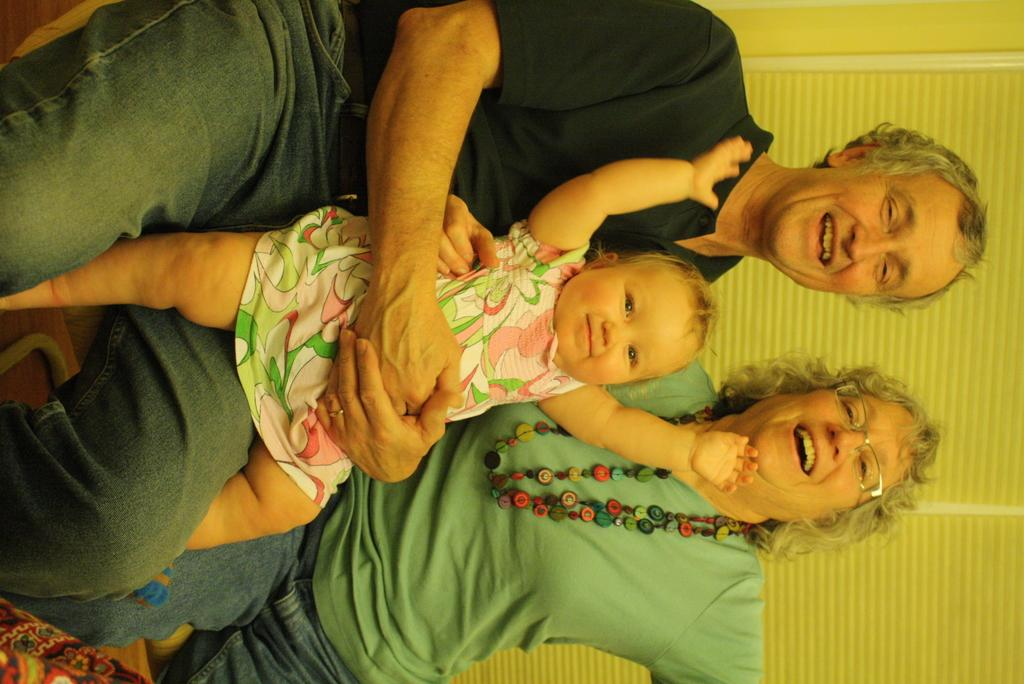What are the people in the image doing? The persons in the front of the image are sitting. What expression do the people have? The persons are smiling. What can be seen in the background of the image? There is a window in the background of the image. Can you see a ghost sitting with the persons in the image? No, there is no ghost present in the image. What type of journey are the persons embarking on in the image? The image does not depict a journey; it simply shows persons sitting and smiling. 